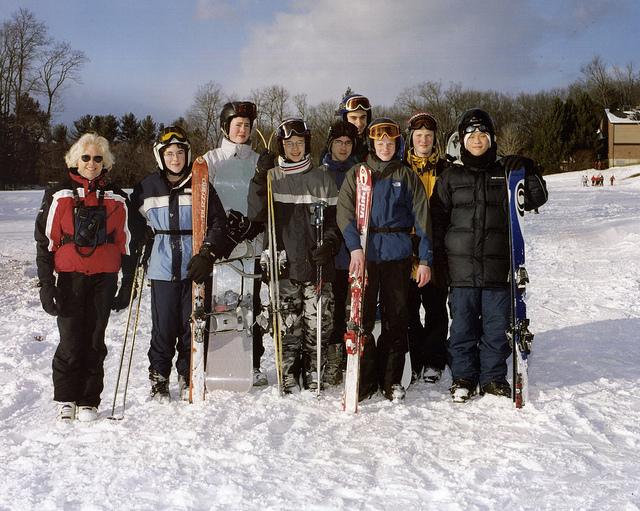What is the likely season?
Answer briefly. Winter. Are they skiing?
Answer briefly. Yes. Are any of the people holding a pair of skis?
Write a very short answer. Yes. Are the people in this photo all in one family?
Give a very brief answer. Yes. 